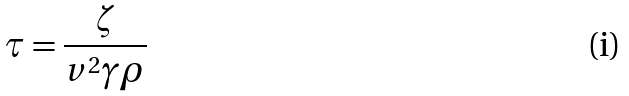<formula> <loc_0><loc_0><loc_500><loc_500>\tau = \frac { \zeta } { v ^ { 2 } \gamma \rho }</formula> 